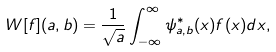<formula> <loc_0><loc_0><loc_500><loc_500>W [ f ] ( a , b ) = \frac { 1 } { \sqrt { a } } \int _ { - \infty } ^ { \infty } \psi _ { a , b } ^ { * } ( x ) f ( x ) d x ,</formula> 